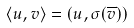Convert formula to latex. <formula><loc_0><loc_0><loc_500><loc_500>\langle u , v \rangle = ( u , \sigma ( \overline { v } ) )</formula> 